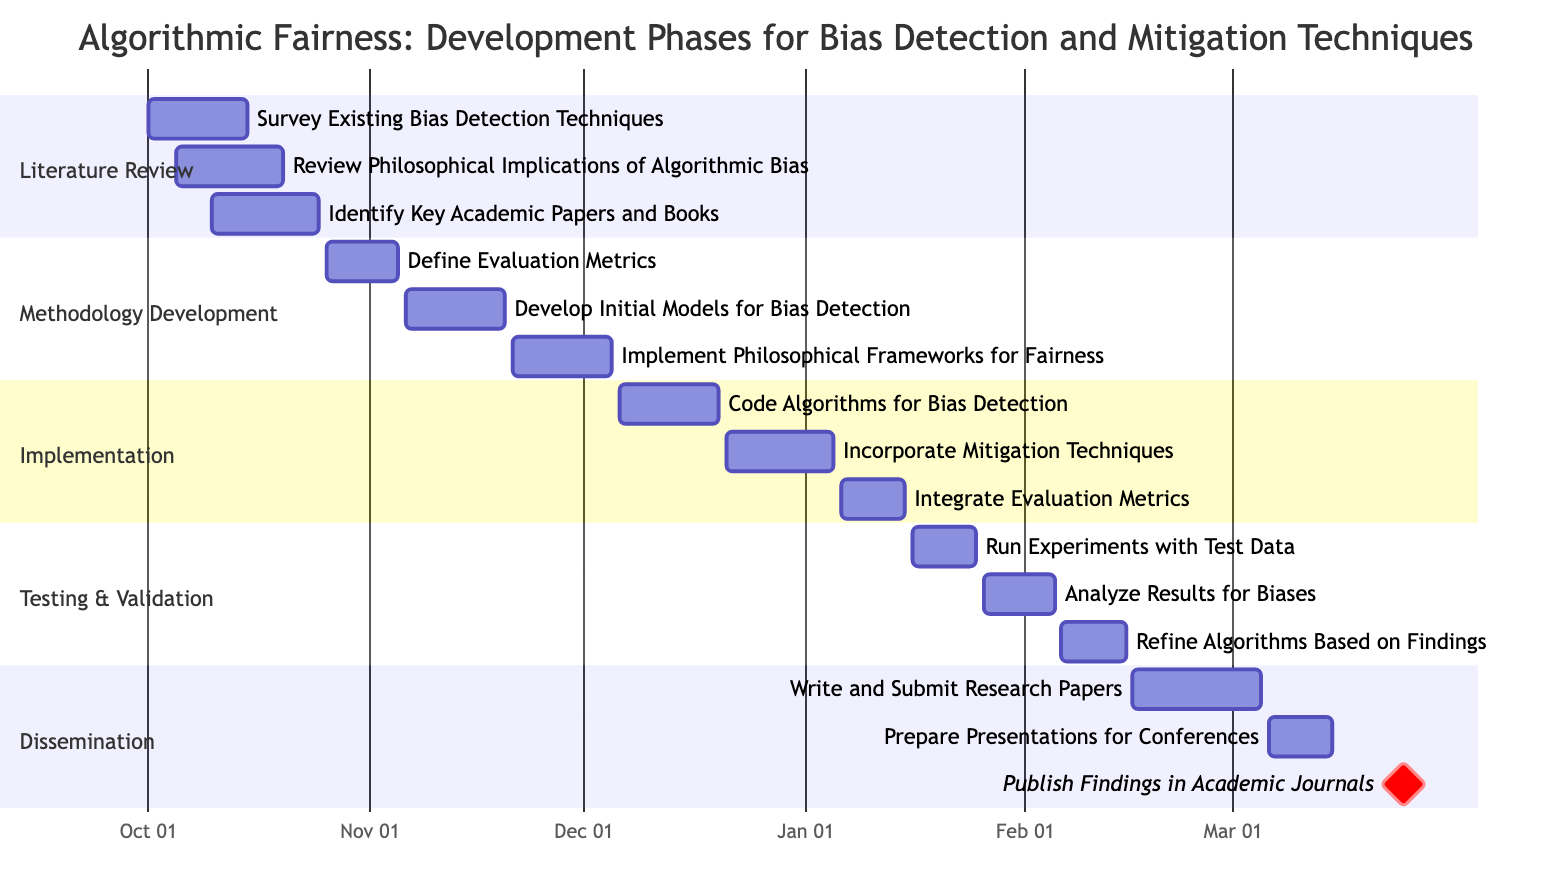What is the duration of the Literature Review phase? The Literature Review phase includes three tasks, starting from October 1, 2023, to October 25, 2023. The duration is from the start to the end date: October 1 to October 25. The total duration is 25 days.
Answer: 25 days How many tasks are there in the Methodology Development phase? The Methodology Development phase consists of three specific tasks: Define Evaluation Metrics, Develop Initial Models for Bias Detection, and Implement Philosophical Frameworks for Fairness. Thus, the number of tasks is counted directly from the phase section.
Answer: 3 What is the last task in the Dissemination phase? In the Dissemination phase, the tasks listed in order are: Write and Submit Research Papers, Prepare Presentations for Conferences, and Publish Findings in Academic Journals. The last task is identified as the one mentioned last in the phase.
Answer: Publish Findings in Academic Journals When does the Testing & Validation phase start? The Testing & Validation phase starts after the Implementation phase, which ends on January 15, 2024. The first task in the Testing & Validation phase, Run Experiments with Test Data, is scheduled to begin on January 16, 2024. Therefore, the starting date is confirmed based on the task start date in the chart.
Answer: January 16, 2024 Which task overlaps with the Analyze Results for Biases task in the Testing & Validation phase? Analyzing Results for Biases occurs from January 26, 2024, to February 5, 2024. The task before it, Run Experiments with Test Data, spans from January 16, 2024, to January 25, 2024. Hence, there are no overlapping tasks, but the next task, Refine Algorithms Based on Findings, starts immediately afterward. Thus, no earlier task overlaps.
Answer: No overlapping task 